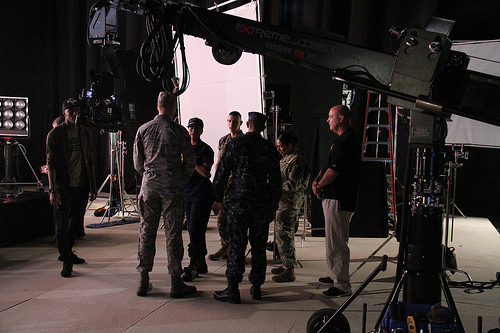<image>
Is there a man behind the man? No. The man is not behind the man. From this viewpoint, the man appears to be positioned elsewhere in the scene. 